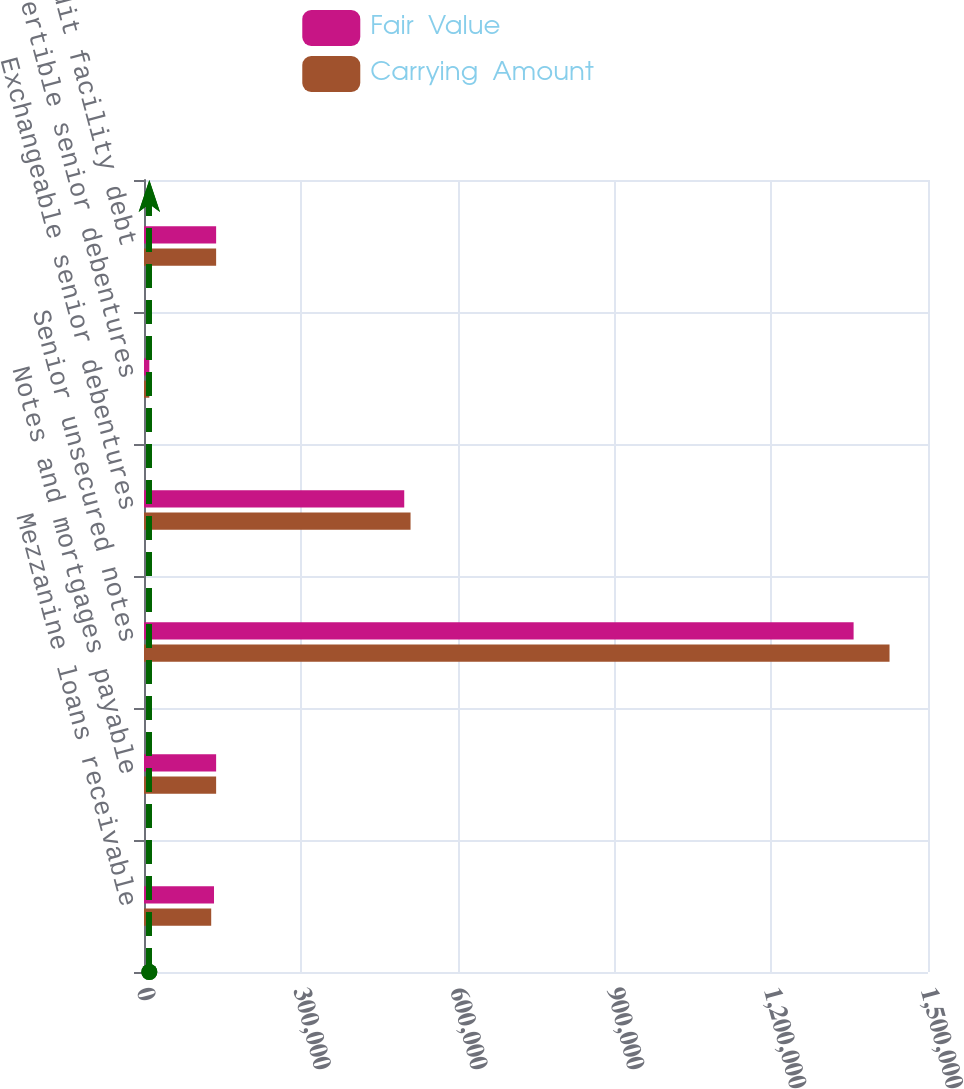Convert chart. <chart><loc_0><loc_0><loc_500><loc_500><stacked_bar_chart><ecel><fcel>Mezzanine loans receivable<fcel>Notes and mortgages payable<fcel>Senior unsecured notes<fcel>Exchangeable senior debentures<fcel>Convertible senior debentures<fcel>Revolving credit facility debt<nl><fcel>Fair  Value<fcel>133948<fcel>138000<fcel>1.35766e+06<fcel>497898<fcel>10168<fcel>138000<nl><fcel>Carrying  Amount<fcel>128581<fcel>138000<fcel>1.42641e+06<fcel>509982<fcel>10220<fcel>138000<nl></chart> 